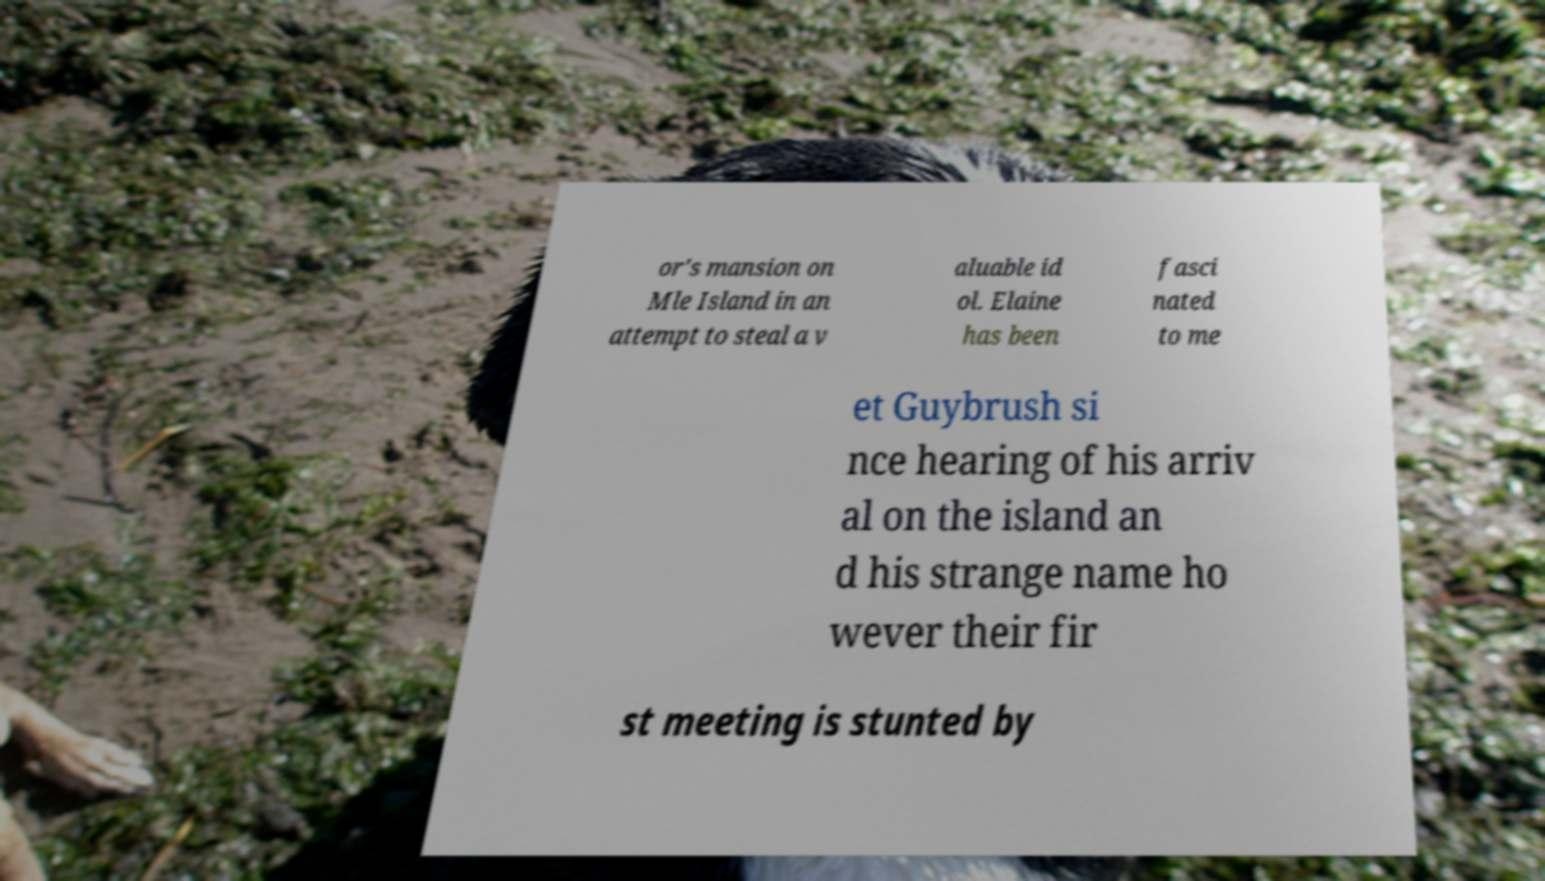Please read and relay the text visible in this image. What does it say? or's mansion on Mle Island in an attempt to steal a v aluable id ol. Elaine has been fasci nated to me et Guybrush si nce hearing of his arriv al on the island an d his strange name ho wever their fir st meeting is stunted by 